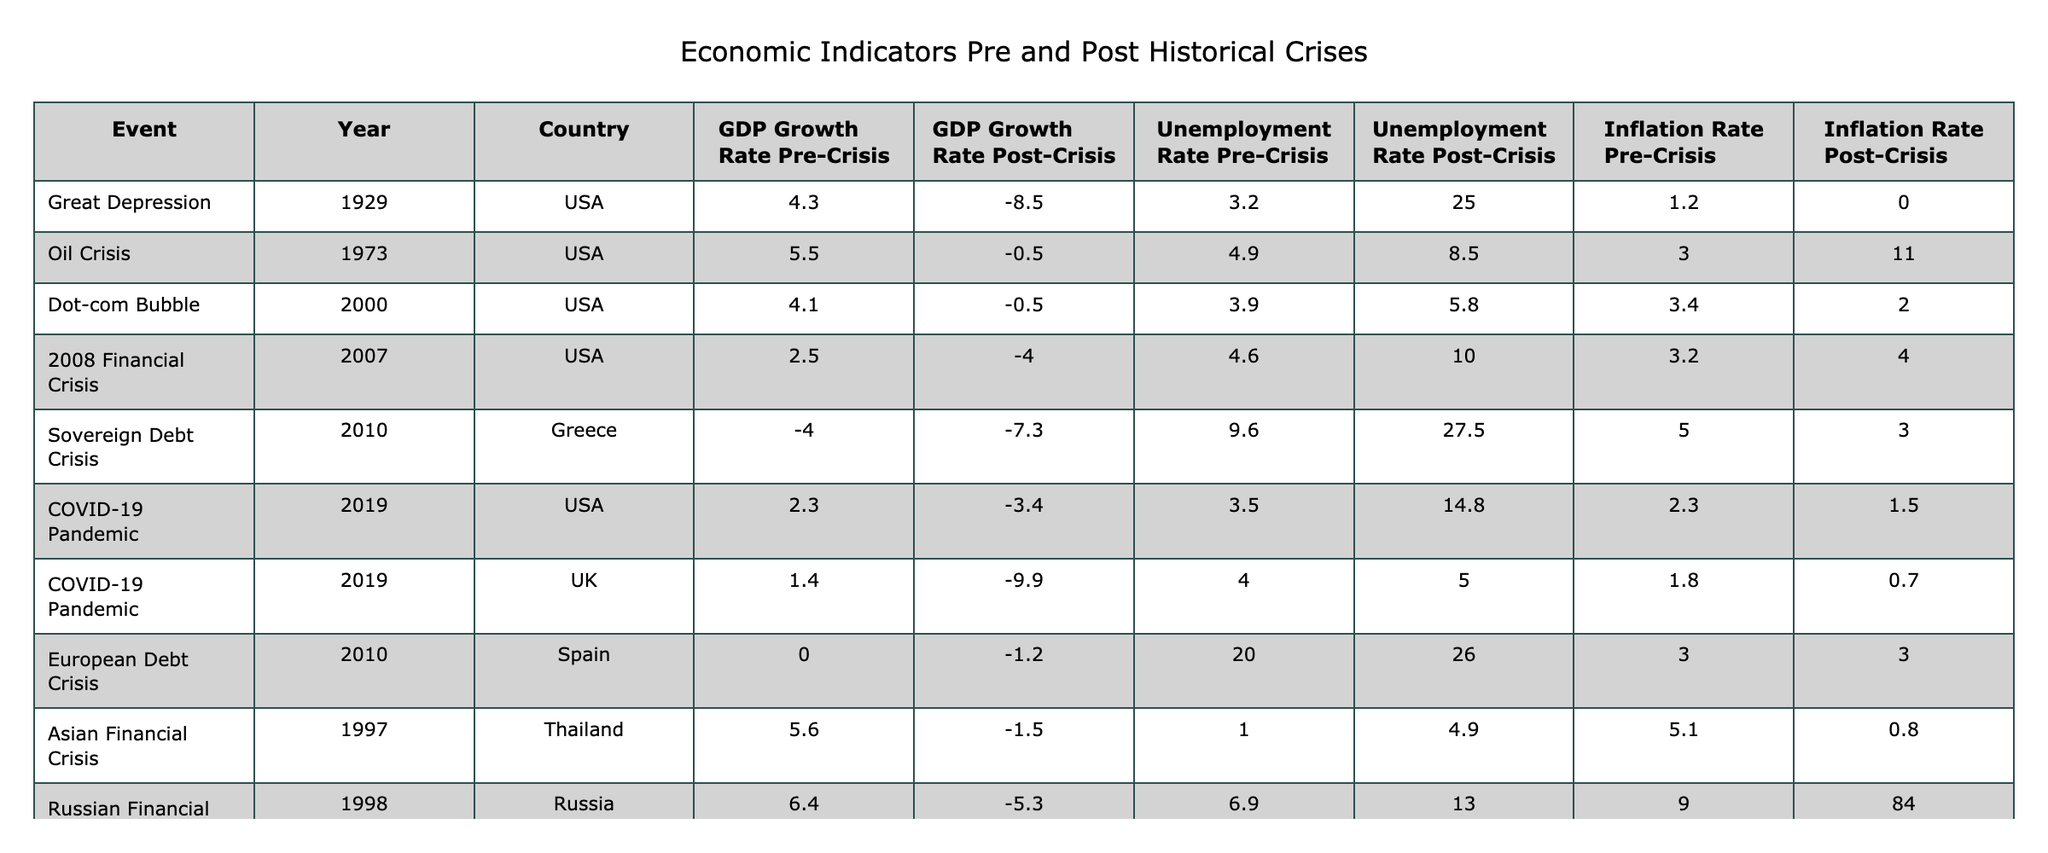What was the GDP growth rate in the USA during the Great Depression? According to the table, the GDP growth rate pre-crisis was 4.3, and post-crisis it was -8.5. Therefore, the GDP growth rate pre-crisis during the Great Depression was 4.3.
Answer: 4.3 What was the unemployment rate in Greece before the Sovereign Debt Crisis? The table indicates that the unemployment rate pre-crisis in Greece was 9.6 before the Sovereign Debt Crisis.
Answer: 9.6 How much did the unemployment rate change in the USA from pre-crisis to post-crisis during the 2008 Financial Crisis? The pre-crisis unemployment rate was 4.6 and post-crisis it was 10.0. The change is calculated as 10.0 - 4.6 = 5.4.
Answer: 5.4 Which event had the highest inflation rate post-crisis? By examining the post-crisis inflation rates, the Russian Financial Crisis had the highest post-crisis inflation rate of 84.0.
Answer: 84.0 Was the GDP growth rate post-crisis higher or lower in the UK compared to the USA during the COVID-19 Pandemic? The post-crisis GDP growth rate in the UK was -9.9, while in the USA it was -3.4. Since -9.9 is lower than -3.4, the UK had a lower post-crisis GDP growth rate.
Answer: Lower What is the average GDP growth rate pre-crisis for the events listed in the table? Summing up the pre-crisis GDP growth rates (4.3 + 5.5 + 4.1 + 2.5 - 4.0 + 2.3 + 1.4 + 0.0 + 5.6 + 6.4) gives a total of 23.1. There are 10 data points, so the average is 23.1 / 10 = 2.31.
Answer: 2.31 Which country experienced the largest increase in the unemployment rate from pre-crisis to post-crisis based on the data provided? To find the largest increase, we calculate the difference for each country: USA in the Great Depression (25.0 - 3.2 = 21.8), Greece (27.5 - 9.6 = 17.9), and USA in 2008 (10.0 - 4.6 = 5.4), etc. The USA during the Great Depression had the highest increase at 21.8.
Answer: USA during the Great Depression Comparing the pre-crisis inflation rates, which historical event had the lowest rate? The pre-crisis inflation rates for the events are: 1.2 (Great Depression), 3.0 (Oil Crisis), 3.4 (Dot-com Bubble), 3.2 (2008 Financial Crisis), 5.0 (Sovereign Debt Crisis), 2.3 (COVID-19, USA), 1.8 (COVID-19, UK), 3.0 (European Debt Crisis), 5.1 (Asian Financial Crisis), 9.0 (Russian Financial Crisis). The lowest is 1.2 from the Great Depression.
Answer: 1.2 What is the difference in inflation rates pre-crisis and post-crisis for the Oil Crisis in the USA? The pre-crisis inflation rate was 3.0, and the post-crisis rate was 11.0. The difference is calculated as 11.0 - 3.0 = 8.0.
Answer: 8.0 